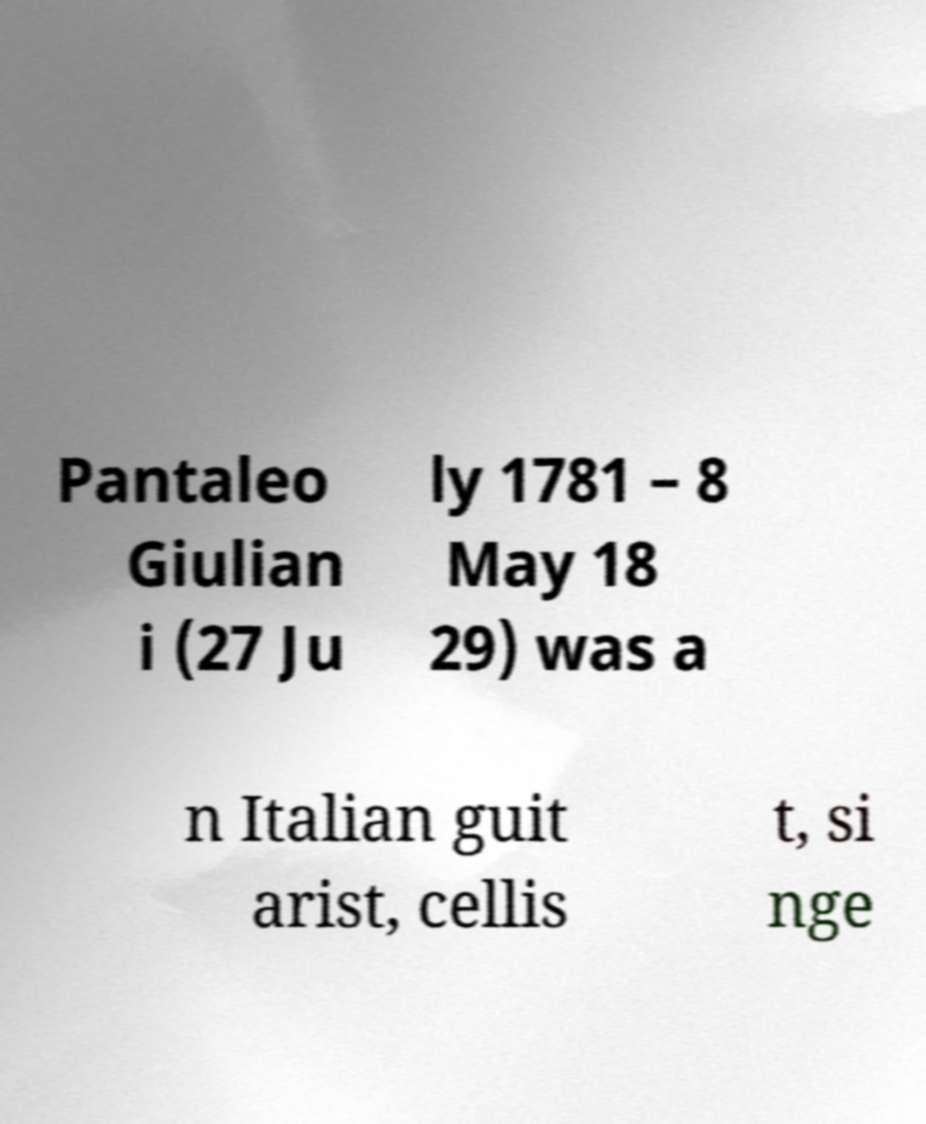For documentation purposes, I need the text within this image transcribed. Could you provide that? Pantaleo Giulian i (27 Ju ly 1781 – 8 May 18 29) was a n Italian guit arist, cellis t, si nge 